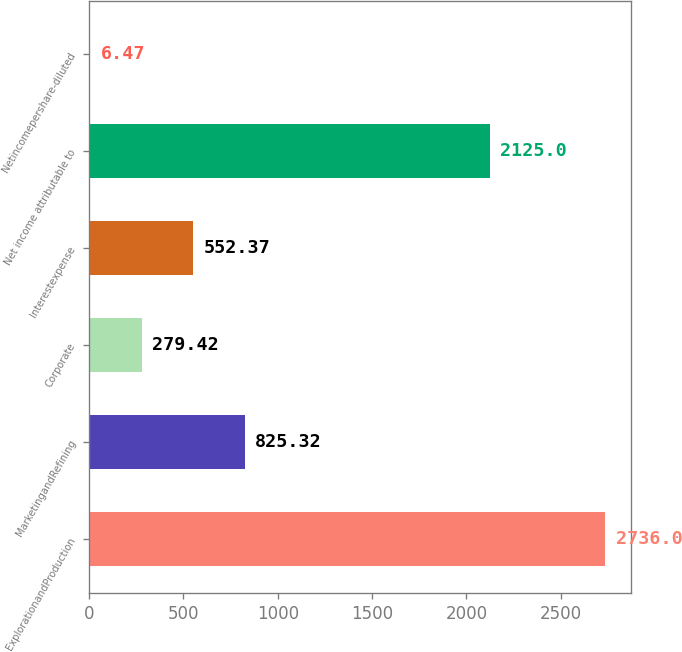Convert chart to OTSL. <chart><loc_0><loc_0><loc_500><loc_500><bar_chart><fcel>ExplorationandProduction<fcel>MarketingandRefining<fcel>Corporate<fcel>Interestexpense<fcel>Net income attributable to<fcel>Netincomepershare-diluted<nl><fcel>2736<fcel>825.32<fcel>279.42<fcel>552.37<fcel>2125<fcel>6.47<nl></chart> 